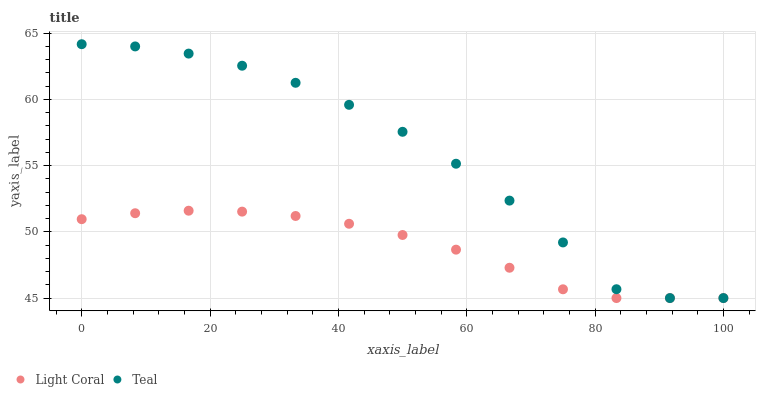Does Light Coral have the minimum area under the curve?
Answer yes or no. Yes. Does Teal have the maximum area under the curve?
Answer yes or no. Yes. Does Teal have the minimum area under the curve?
Answer yes or no. No. Is Light Coral the smoothest?
Answer yes or no. Yes. Is Teal the roughest?
Answer yes or no. Yes. Is Teal the smoothest?
Answer yes or no. No. Does Light Coral have the lowest value?
Answer yes or no. Yes. Does Teal have the highest value?
Answer yes or no. Yes. Does Light Coral intersect Teal?
Answer yes or no. Yes. Is Light Coral less than Teal?
Answer yes or no. No. Is Light Coral greater than Teal?
Answer yes or no. No. 